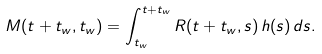Convert formula to latex. <formula><loc_0><loc_0><loc_500><loc_500>M ( t + t _ { w } , t _ { w } ) = \int _ { t _ { w } } ^ { t + t _ { w } } R ( t + t _ { w } , s ) \, h ( s ) \, d s .</formula> 